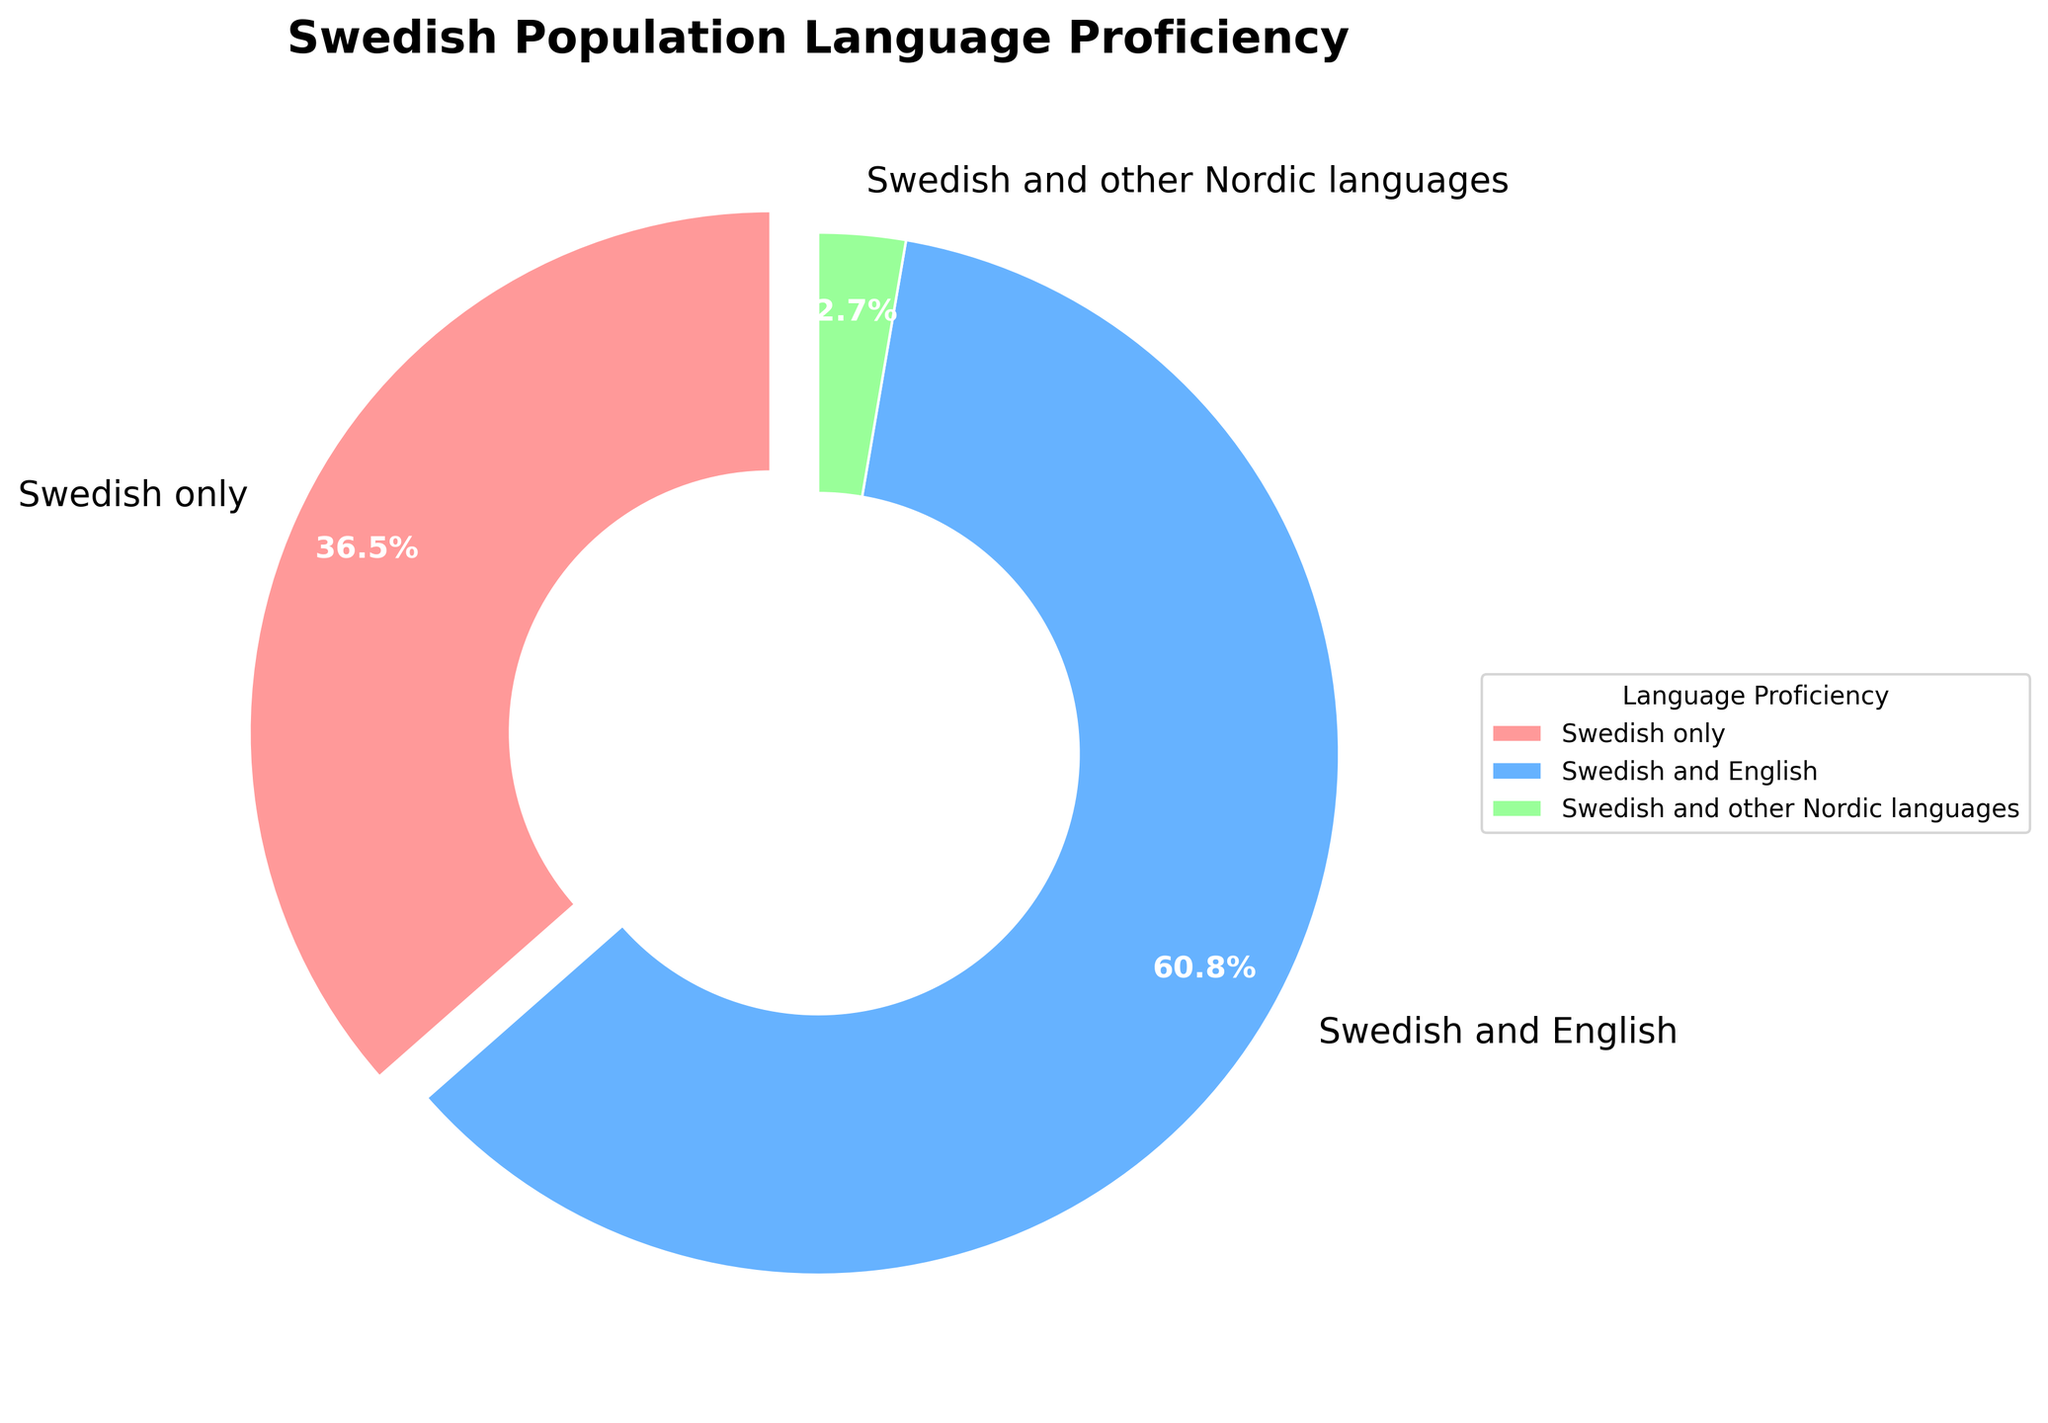What percentage of the Swedish population is fluent in only Swedish? The figure shows the percentage of the population fluent in only Swedish. According to the chart, it is 27%.
Answer: 27% Which language proficiency group constitutes the largest portion of the Swedish population? By observing the slices of the pie chart, the largest slice is labeled "Swedish and English", which indicates it has the highest percentage.
Answer: Swedish and English What is the total percentage of the Swedish population fluent in multiple languages? Adding the percentages of the groups fluent in Swedish and English (45%) and Swedish and other Nordic languages (2%) totals to 47%.
Answer: 47% How much larger is the percentage of people fluent in Swedish and English compared to those fluent in Swedish only? Subtract the percentage of people fluent in only Swedish (27%) from the percentage of people fluent in Swedish and English (45%): 45% - 27% = 18%.
Answer: 18% Which color represents the group fluent in only Swedish? The color representing "Swedish only" can be identified in the pie chart legend as the first segment, which is red.
Answer: Red Does the percentage of people fluent in Swedish and other Nordic languages exceed 5%? According to the chart, the percentage of people fluent in Swedish and other Nordic languages is 2%, which is less than 5%.
Answer: No What percentage of the population is not fluent in English? Subtract the percentage of people fluent in Swedish and English (45%) from 100% to find those not fluent in English: 100% - 45% = 55%.
Answer: 55% What’s the difference between the percentages of people fluent in "Swedish only" and "Swedish and other Nordic languages"? Subtract the percentage of people fluent in Swedish and other Nordic languages (2%) from the percentage of people fluent in only Swedish (27%): 27% - 2% = 25%.
Answer: 25% If you combine the groups fluent in "Swedish and English" and "Swedish and other Nordic languages," what percentage of the population speaks at least one other language apart from Swedish? Adding the percentages of "Swedish and English" (45%) and "Swedish and other Nordic languages" (2%) gives 45% + 2% = 47%.
Answer: 47% 